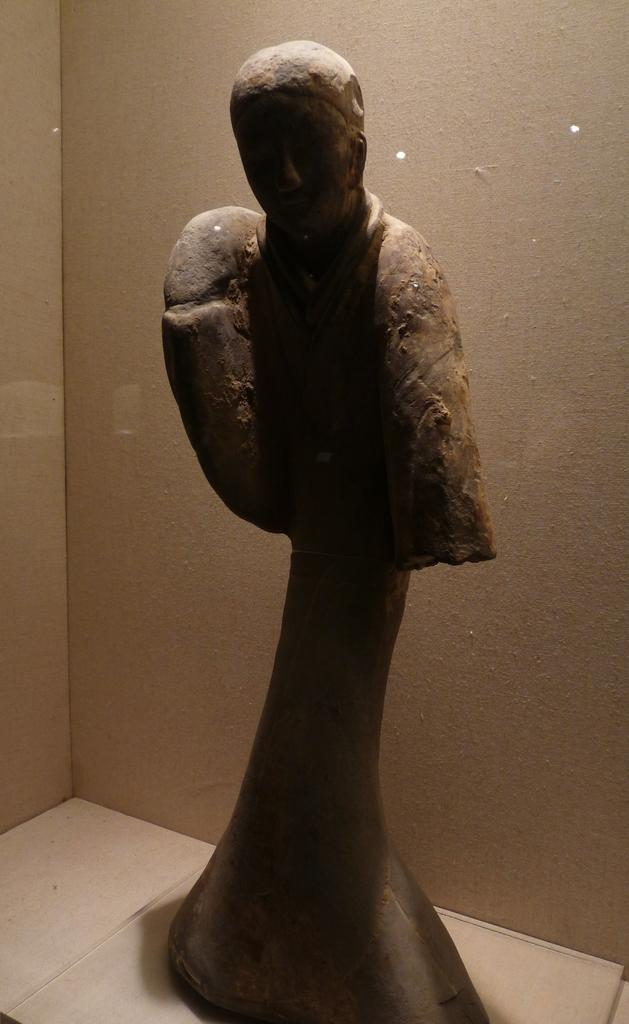What is the main subject of the image? There is a statue of a person in the image. What is the color of the statue? The statue is black in color. What can be seen in the background of the image? There is a wall visible in the background of the image. Is there a boat in the image? No, there is no boat present in the image. Can you see a volleyball being played in the image? No, there is no volleyball or any indication of a game being played in the image. 